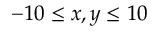Convert formula to latex. <formula><loc_0><loc_0><loc_500><loc_500>- 1 0 \leq x , y \leq 1 0</formula> 